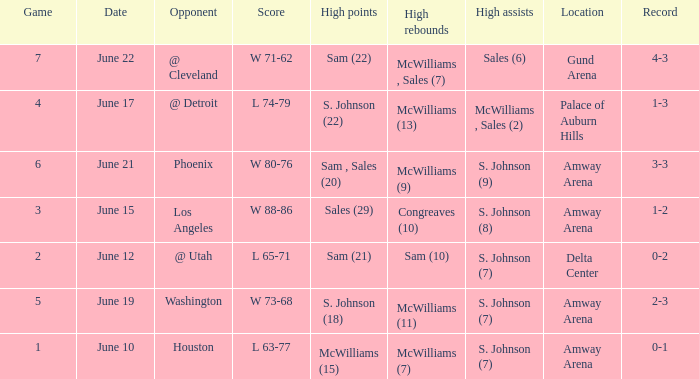Name the total number of date for  l 63-77 1.0. 